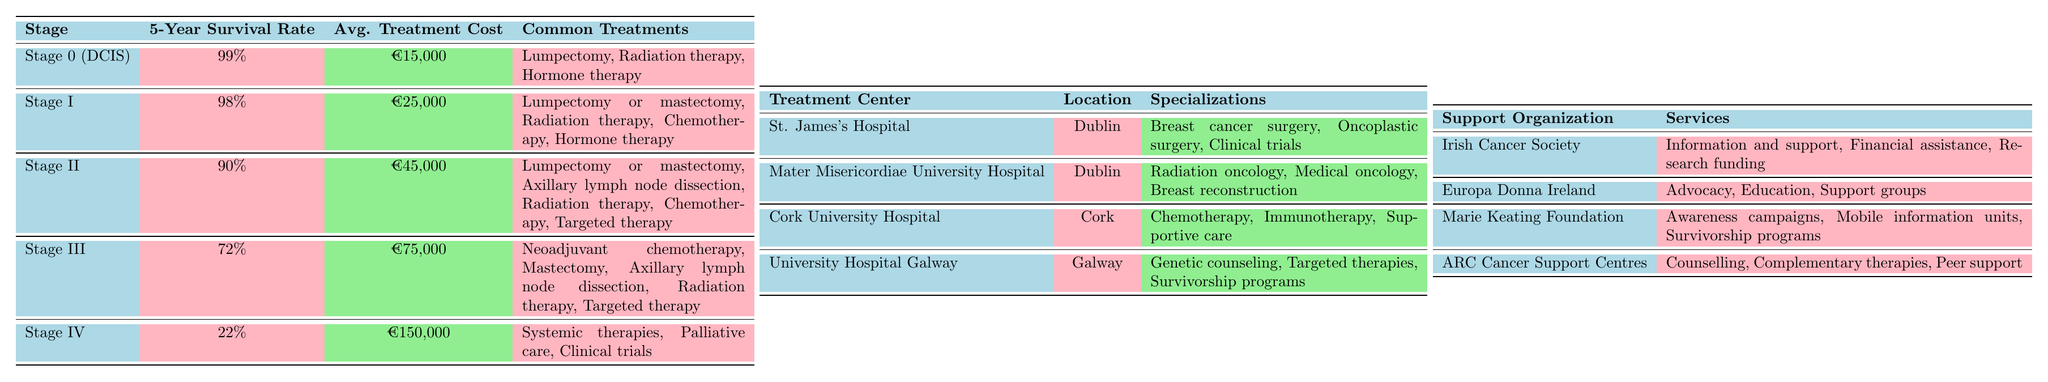What is the 5-Year Survival Rate for Stage II breast cancer? The table shows that the 5-Year Survival Rate for Stage II breast cancer is listed as 90%.
Answer: 90% What is the Average Treatment Cost for Stage IV breast cancer? According to the table, the Average Treatment Cost for Stage IV breast cancer is €150,000.
Answer: €150,000 How many stages have a 5-Year Survival Rate of 90% or higher? The stages with a 5-Year Survival Rate of 90% or higher are Stage 0 (99%), Stage I (98%), and Stage II (90%). There are 3 such stages.
Answer: 3 What are the common treatments for Stage I breast cancer? The table lists the common treatments for Stage I as Lumpectomy or mastectomy, Radiation therapy, Chemotherapy, and Hormone therapy.
Answer: Lumpectomy or mastectomy, Radiation therapy, Chemotherapy, Hormone therapy Is the average treatment cost for Stage III breast cancer higher than that for Stage I? Comparing the two values, the Average Treatment Cost for Stage III is €75,000 and for Stage I is €25,000. €75,000 is indeed greater than €25,000.
Answer: Yes What is the difference in 5-Year Survival Rate between Stage I and Stage IV? The 5-Year Survival Rate for Stage I is 98% and for Stage IV is 22%. The difference is 98% - 22% = 76%.
Answer: 76% Which treatment centers provide chemotherapy as a specialization? The table mentions Cork University Hospital as a treatment center that specializes in Chemotherapy.
Answer: Cork University Hospital Which support organization offers financial assistance? The Irish Cancer Society provides financial assistance as one of its services according to the table.
Answer: Irish Cancer Society What is the average treatment cost for stages with a survival rate under 75%? The stages under 75% survival rate are Stage III (72% at €75,000) and Stage IV (22% at €150,000). The average cost is (€75,000 + €150,000) / 2 = €112,500.
Answer: €112,500 Are there any treatment centers located in Galway? Yes, the table lists University Hospital Galway, which is located in Galway.
Answer: Yes 